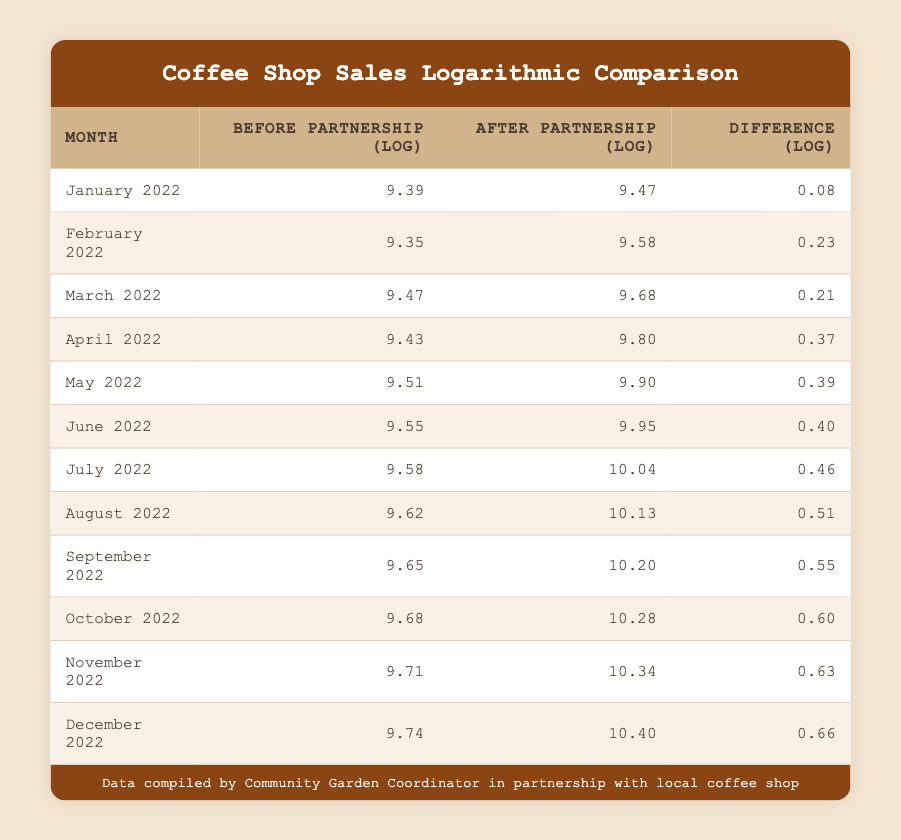What were the sales after the partnership in December 2022? The table lists sales after partnership for each month. In December 2022, the sales after partnership are shown as 33000.
Answer: 33000 What is the difference in sales before and after the partnership for August 2022? For August 2022, the sales before partnership were 15000, and sales after were 25000. The difference is calculated as 25000 - 15000 = 10000.
Answer: 10000 Which month had the largest increase in sales after the partnership? By examining the "Difference (log)" column, December 2022 has the highest value of 0.66, indicating the largest increase in sales after the partnership.
Answer: December 2022 Was the average sales before partnership greater than 14000? The average sales before partnership can be calculated by summing the sales and dividing by the number of months. The sum is 12000 + 11500 + 13000 + 12500 + 13500 + 14000 + 14500 + 15000 + 15500 + 16000 + 16500 + 17000 = 171000. Dividing 171000 by 12 gives an average of 14250, which is greater than 14000.
Answer: Yes In how many months did the sales after partnership exceed 25000? Looking at the "After Partnership" column, the months where sales exceeded 25000 are August 2022, September 2022, October 2022, November 2022, and December 2022. Counting these, there are 5 months.
Answer: 5 What is the difference in logarithmic values for sales before and after partnership in April 2022? For April 2022, sales before the partnership correspond to a logarithmic value of 9.43, while sales after partnership have a value of 9.80, making the difference 9.80 - 9.43 = 0.37.
Answer: 0.37 Which month had the highest logarithmic sales before the partnership? By checking the "Before Partnership (log)" column, we see that December 2022 has the highest value of 9.74.
Answer: December 2022 Did the sales after partnership in June 2022 reach 20000? The data for June 2022 shows that the sales after partnership were 21000, which is indeed higher than 20000.
Answer: Yes What is the total logarithmic difference for all months combined? To find the total logarithmic difference, we sum up all the differences from the "Difference (log)" column: 0.08 + 0.23 + 0.21 + 0.37 + 0.39 + 0.40 + 0.46 + 0.51 + 0.55 + 0.60 + 0.63 + 0.66 = 5.49.
Answer: 5.49 